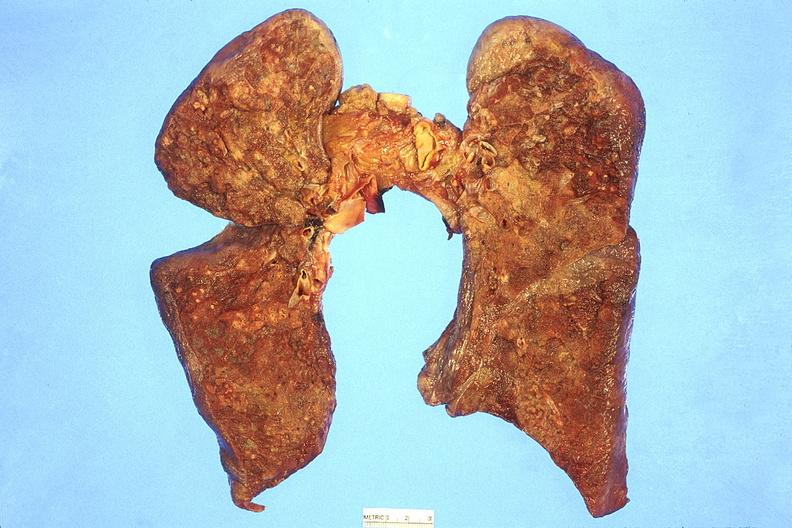s respiratory present?
Answer the question using a single word or phrase. Yes 